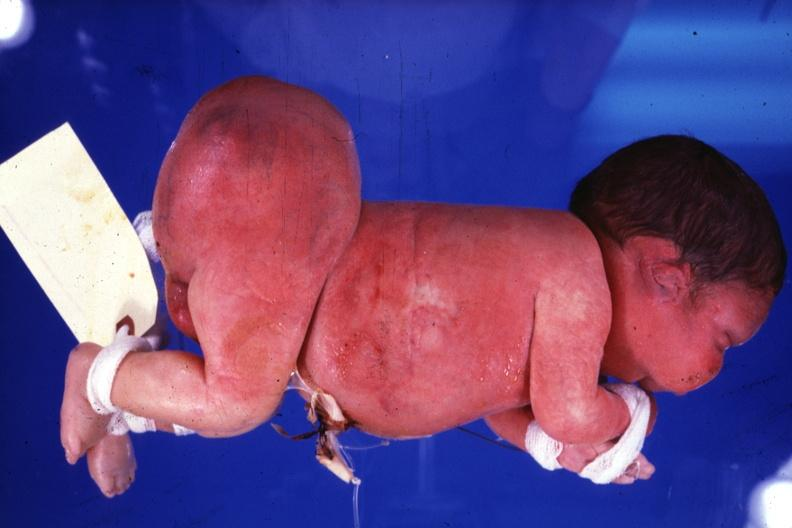what does this image show?
Answer the question using a single word or phrase. Lateral view of body with grossly enlarged buttocks area 